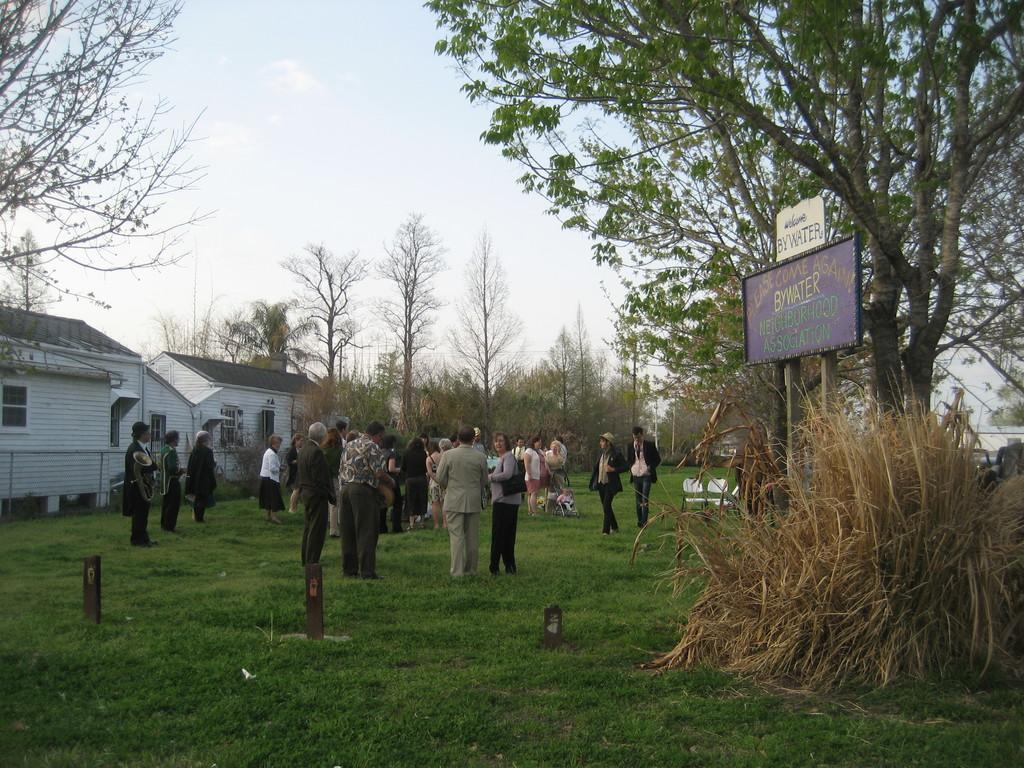What are the people in the image standing on? The people in the image are standing on the grass. Can you describe the grass in the image? The grass is visible in the image. What can be seen in the background of the image? There are houses and trees in the background. What type of thought can be seen floating above the people in the image? There are no thoughts visible in the image; it only shows people standing on the grass with houses and trees in the background. 